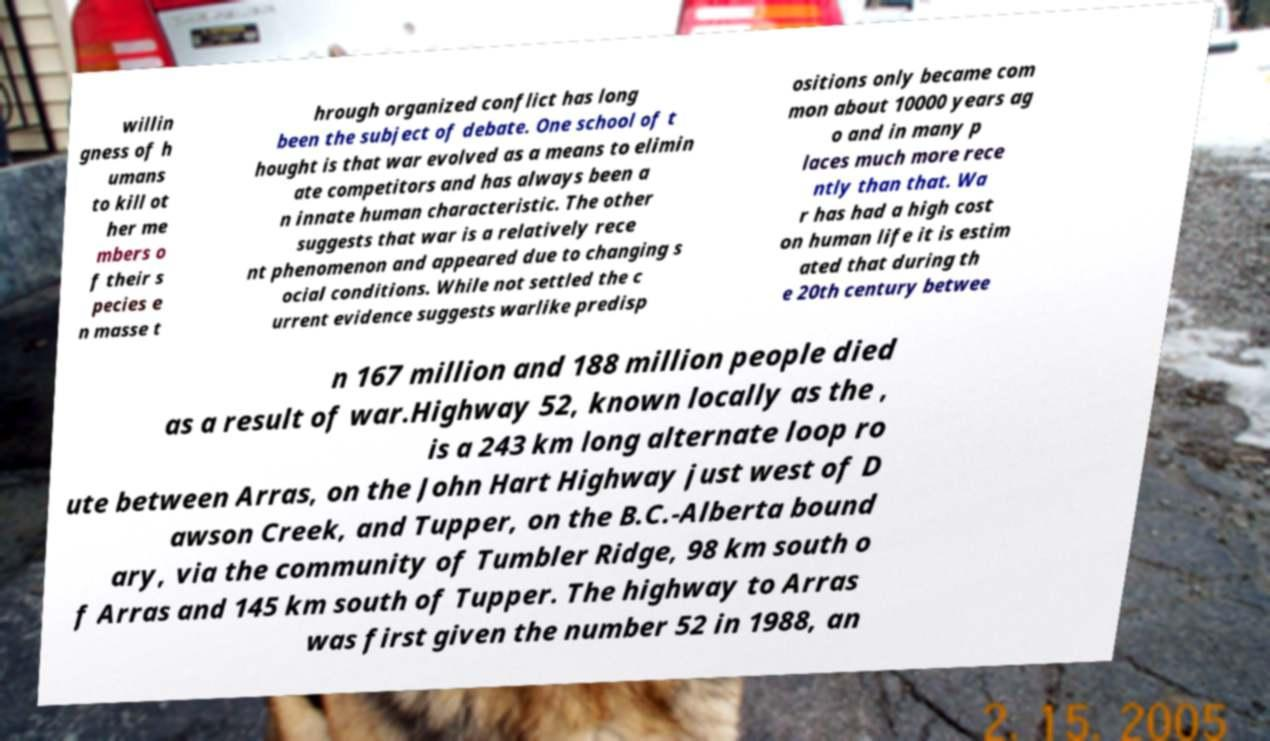Can you accurately transcribe the text from the provided image for me? willin gness of h umans to kill ot her me mbers o f their s pecies e n masse t hrough organized conflict has long been the subject of debate. One school of t hought is that war evolved as a means to elimin ate competitors and has always been a n innate human characteristic. The other suggests that war is a relatively rece nt phenomenon and appeared due to changing s ocial conditions. While not settled the c urrent evidence suggests warlike predisp ositions only became com mon about 10000 years ag o and in many p laces much more rece ntly than that. Wa r has had a high cost on human life it is estim ated that during th e 20th century betwee n 167 million and 188 million people died as a result of war.Highway 52, known locally as the , is a 243 km long alternate loop ro ute between Arras, on the John Hart Highway just west of D awson Creek, and Tupper, on the B.C.-Alberta bound ary, via the community of Tumbler Ridge, 98 km south o f Arras and 145 km south of Tupper. The highway to Arras was first given the number 52 in 1988, an 